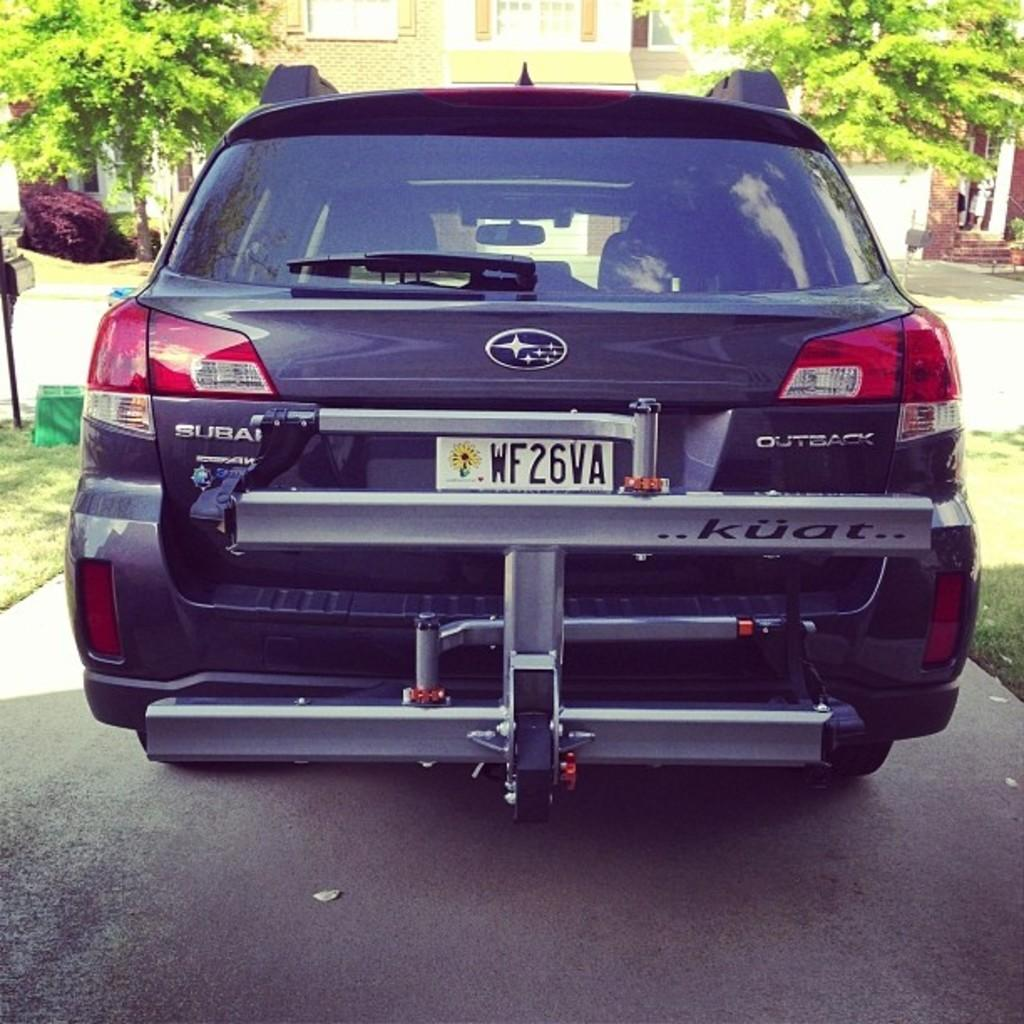<image>
Relay a brief, clear account of the picture shown. A black Subaru with a tag that reads WF26VA. 